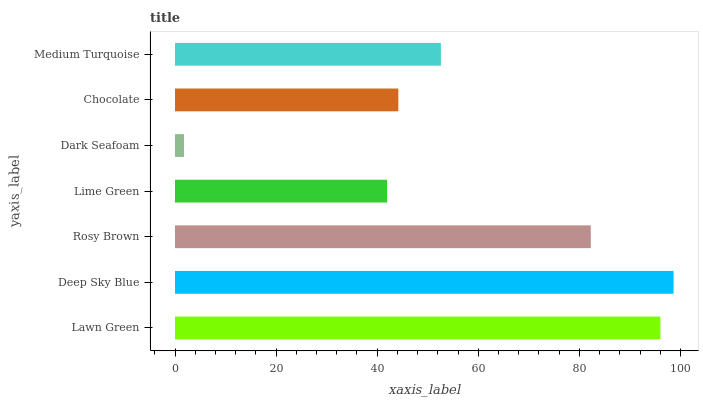Is Dark Seafoam the minimum?
Answer yes or no. Yes. Is Deep Sky Blue the maximum?
Answer yes or no. Yes. Is Rosy Brown the minimum?
Answer yes or no. No. Is Rosy Brown the maximum?
Answer yes or no. No. Is Deep Sky Blue greater than Rosy Brown?
Answer yes or no. Yes. Is Rosy Brown less than Deep Sky Blue?
Answer yes or no. Yes. Is Rosy Brown greater than Deep Sky Blue?
Answer yes or no. No. Is Deep Sky Blue less than Rosy Brown?
Answer yes or no. No. Is Medium Turquoise the high median?
Answer yes or no. Yes. Is Medium Turquoise the low median?
Answer yes or no. Yes. Is Chocolate the high median?
Answer yes or no. No. Is Dark Seafoam the low median?
Answer yes or no. No. 